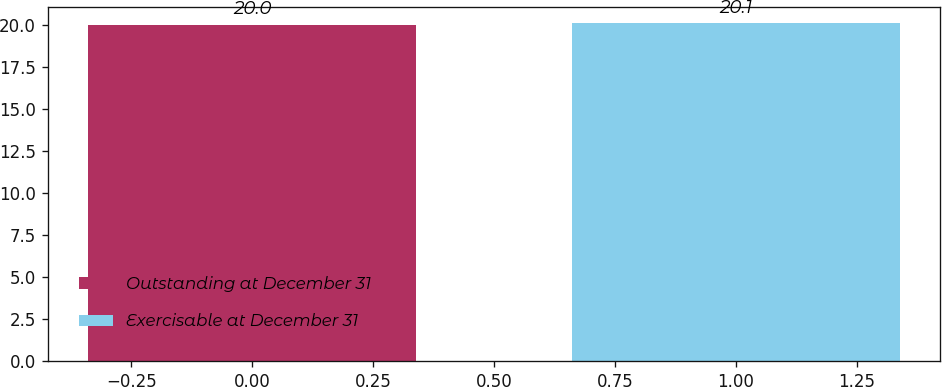Convert chart. <chart><loc_0><loc_0><loc_500><loc_500><bar_chart><fcel>Outstanding at December 31<fcel>Exercisable at December 31<nl><fcel>20<fcel>20.1<nl></chart> 